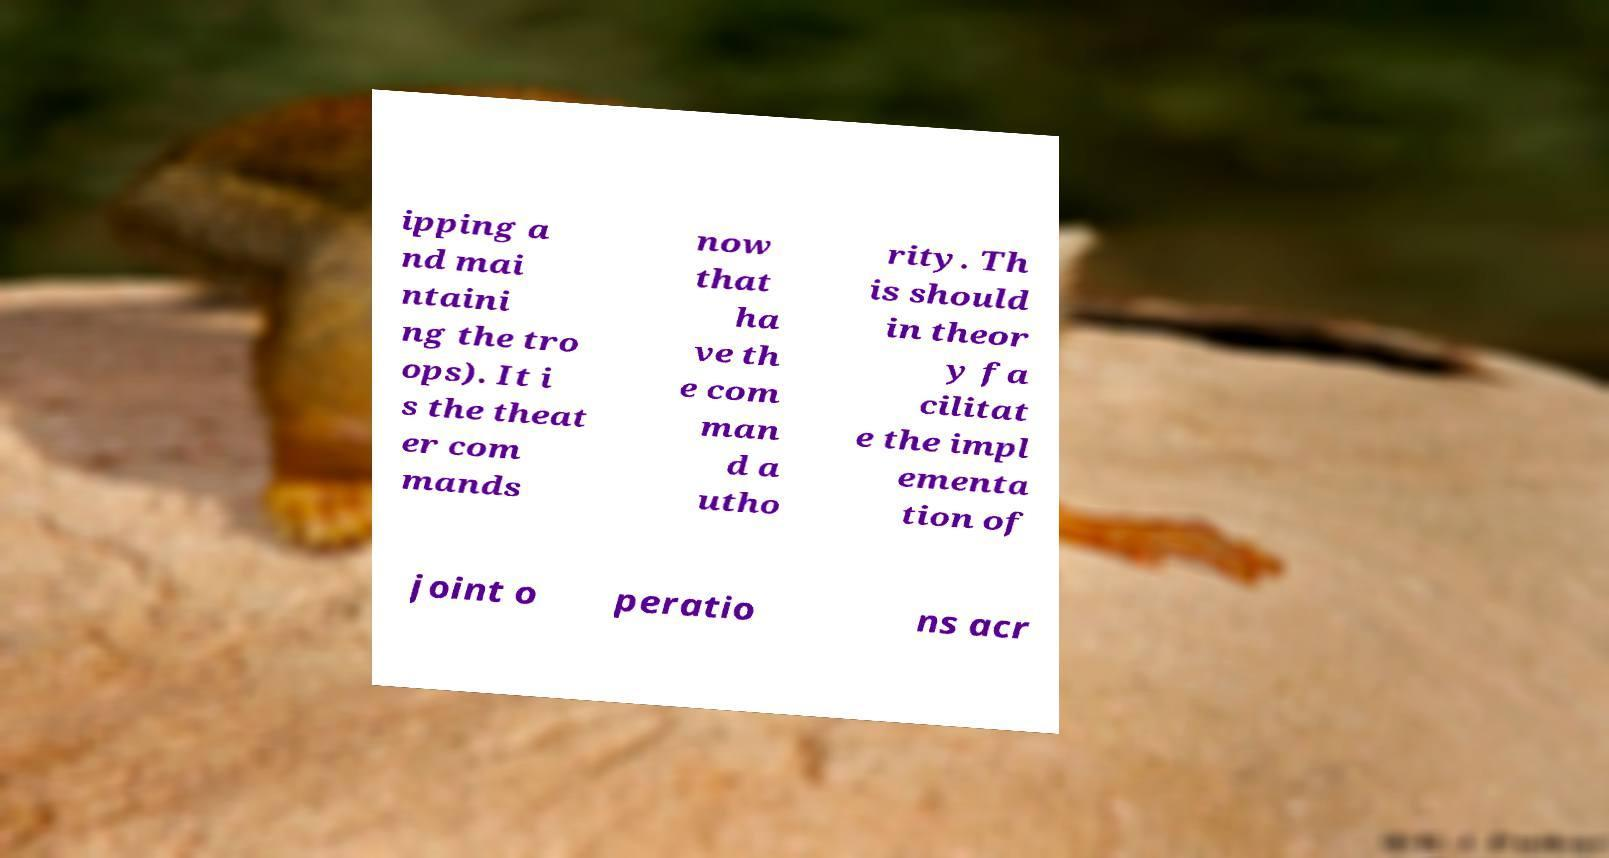Please identify and transcribe the text found in this image. ipping a nd mai ntaini ng the tro ops). It i s the theat er com mands now that ha ve th e com man d a utho rity. Th is should in theor y fa cilitat e the impl ementa tion of joint o peratio ns acr 